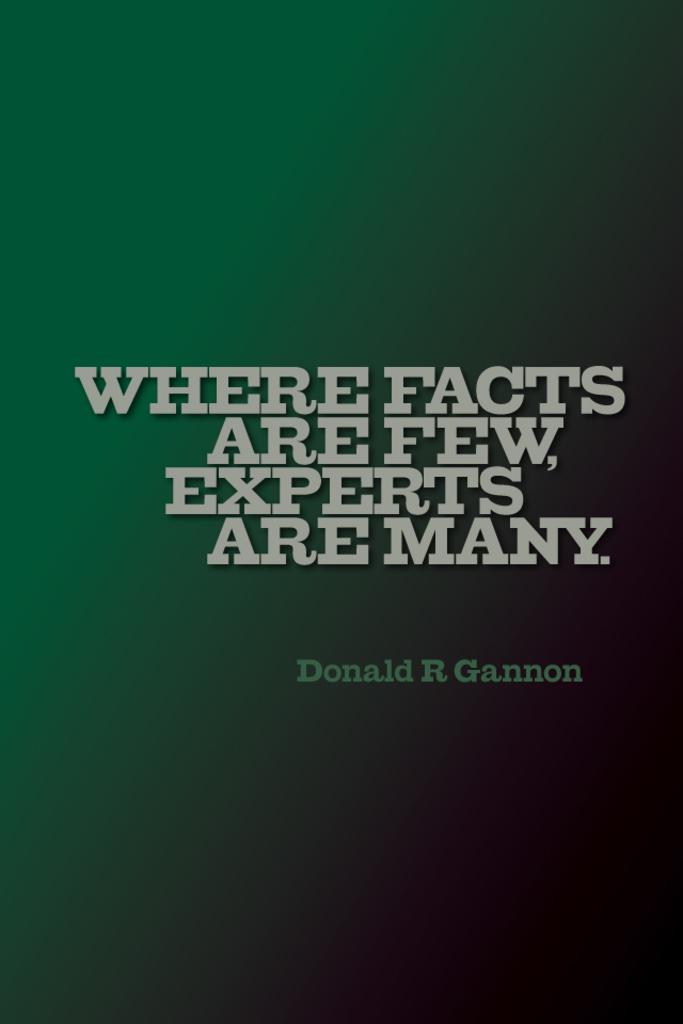<image>
Summarize the visual content of the image. A green book cover that is titled Where Facts Are Few, Experts are Many. 